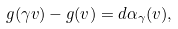Convert formula to latex. <formula><loc_0><loc_0><loc_500><loc_500>g ( \gamma v ) - g ( v ) = d \alpha _ { \gamma } ( v ) ,</formula> 